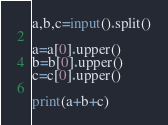<code> <loc_0><loc_0><loc_500><loc_500><_Python_>a,b,c=input().split()

a=a[0].upper()
b=b[0].upper()
c=c[0].upper()

print(a+b+c)
</code> 